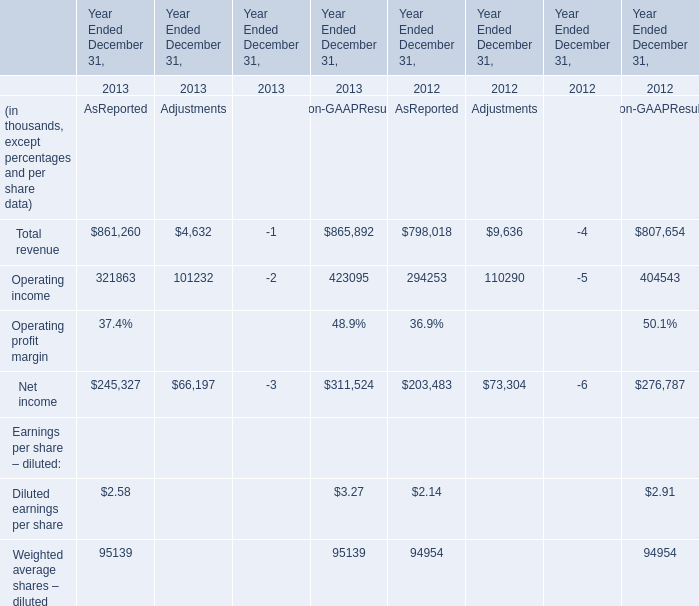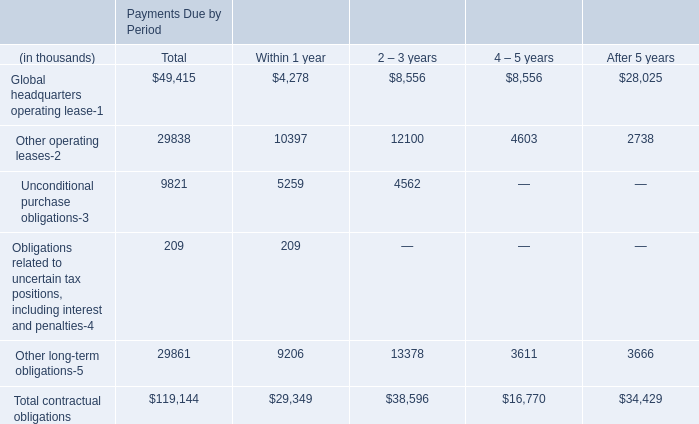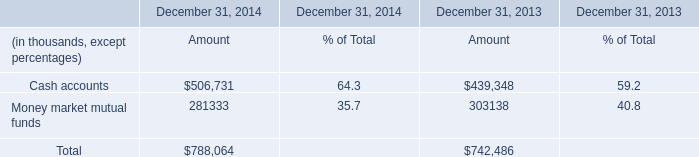What's the difference of Total revenue as reported between 2013 and 2012? (in thousand) 
Computations: (861260 - 798018)
Answer: 63242.0. What is the sum of Cash accounts of December 31, 2013 Amount, and Net income of Year Ended December 31, 2013 AsReported ? 
Computations: (439348.0 + 245327.0)
Answer: 684675.0. what's the total amount of Net income of Year Ended December 31, 2012 AsReported, and Money market mutual funds of December 31, 2013 Amount ? 
Computations: (203483.0 + 303138.0)
Answer: 506621.0. What's the growth rate of Total revenue as reported in 2013? 
Computations: ((861260 - 798018) / 798018)
Answer: 0.07925. 